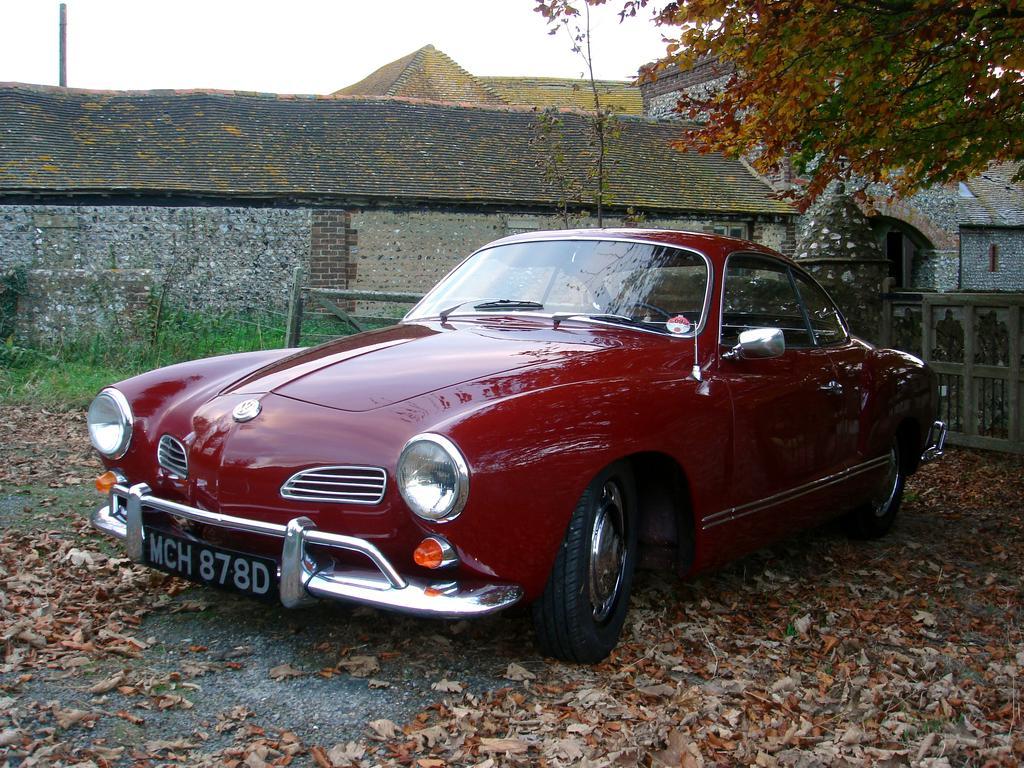How would you summarize this image in a sentence or two? In this image we can see a red color car on the ground where we can see the dry leaves. In the background, we can see the wooden fence, grass, stone house, trees and sky. 